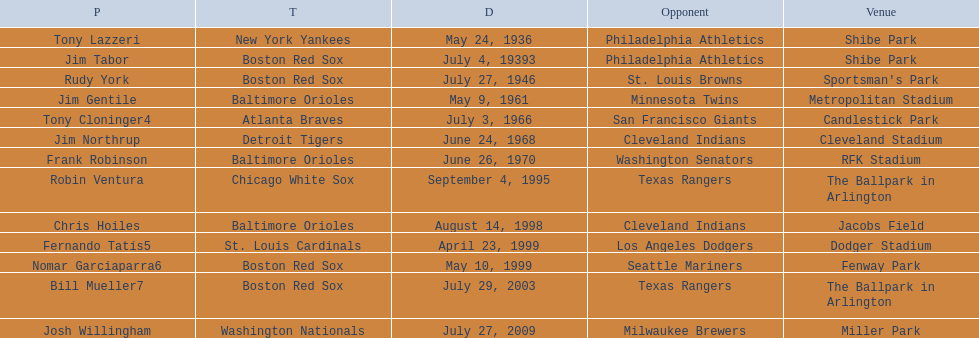Which teams played between the years 1960 and 1970? Baltimore Orioles, Atlanta Braves, Detroit Tigers, Baltimore Orioles. Of these teams that played, which ones played against the cleveland indians? Detroit Tigers. On what day did these two teams play? June 24, 1968. 